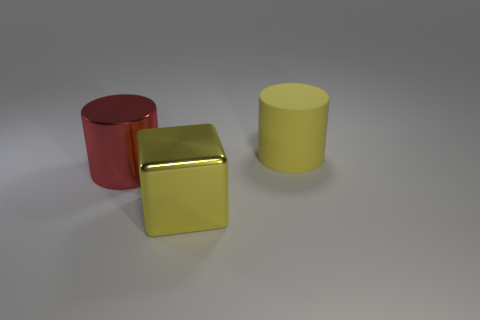Do the yellow metallic block and the metal cylinder have the same size?
Make the answer very short. Yes. There is another large red thing that is the same shape as the large matte thing; what material is it?
Keep it short and to the point. Metal. What is the material of the yellow block that is the same size as the red thing?
Offer a very short reply. Metal. There is another yellow object that is the same size as the yellow metallic thing; what shape is it?
Your response must be concise. Cylinder. There is a cube that is made of the same material as the large red cylinder; what color is it?
Make the answer very short. Yellow. Are there more shiny cubes than cylinders?
Your answer should be very brief. No. How many objects are either yellow objects behind the yellow metal thing or green cylinders?
Your answer should be very brief. 1. Are there any other gray cubes that have the same size as the metallic block?
Provide a short and direct response. No. Are there fewer large red shiny cylinders than small shiny cylinders?
Your answer should be very brief. No. What number of cubes are either large yellow rubber things or shiny objects?
Keep it short and to the point. 1. 